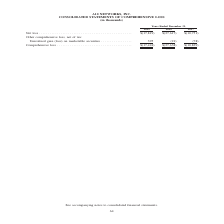According to A10 Networks's financial document, What is the units used to describe the data in the table? According to the financial document, in thousands. The relevant text states: "C. CONSOLIDATED STATEMENTS OF COMPREHENSIVE LOSS (in thousands)..." Also, What is the name of the table that the data is extracted from? CONSOLIDATED STATEMENTS OF COMPREHENSIVE LOSS. The document states: "A10 NETWORKS, INC. CONSOLIDATED STATEMENTS OF COMPREHENSIVE LOSS (in thousands)..." Also, What is the company's net loss in 2019? According to the financial document, $(17,819) (in thousands). The relevant text states: "Net loss . $(17,819) $(27,617) $(10,751) Other comprehensive loss, net of tax: Unrealized gain (loss) on marketable secur..." Also, can you calculate: What is the company's percentage change in net loss between 2018 and 2019? To answer this question, I need to perform calculations using the financial data. The calculation is: ($(-17,424)-$(-27,638))/$(-27,638) , which equals -36.96 (percentage). This is based on the information: "Comprehensive loss . $(17,424) $(27,638) $(10,829) Comprehensive loss . $(17,424) $(27,638) $(10,829)..." The key data points involved are: 17,424, 27,638. Also, can you calculate: What is the company's total unrealized gain on marketable securities between 2017 to 2019? Based on the calculation: 395+(-21)+(-78) , the result is 296 (in thousands). This is based on the information: "gain (loss) on marketable securities . 395 (21) (78) Unrealized gain (loss) on marketable securities . 395 (21) (78) lized gain (loss) on marketable securities . 395 (21) (78)..." The key data points involved are: 21, 395, 78. Also, can you calculate: What is the company's total Comprehensive loss between 2017 to 2019? Based on the calculation: $(-17,424)+$(-27,638)+$(-10,829), the result is -55891 (in thousands). This is based on the information: "Comprehensive loss . $(17,424) $(27,638) $(10,829) Comprehensive loss . $(17,424) $(27,638) $(10,829) Comprehensive loss . $(17,424) $(27,638) $(10,829)..." The key data points involved are: 10,829, 17,424, 27,638. 